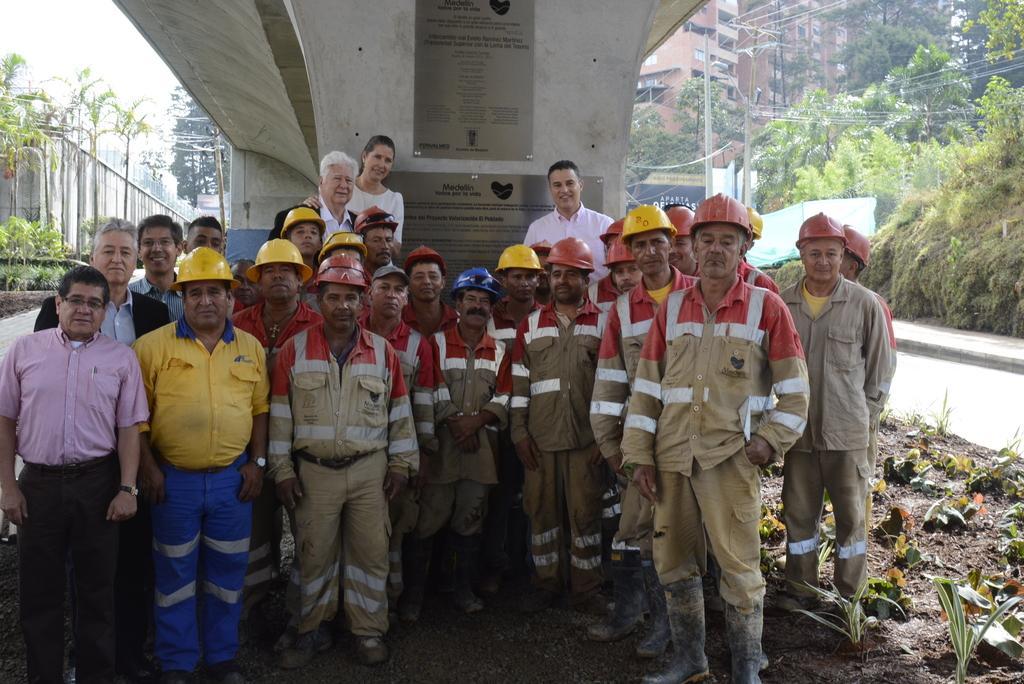Could you give a brief overview of what you see in this image? In this picture I can see number of people who are standing under and on the right side of this image I see few plants. In the background I see number of trees, wires, poles and the buildings. 